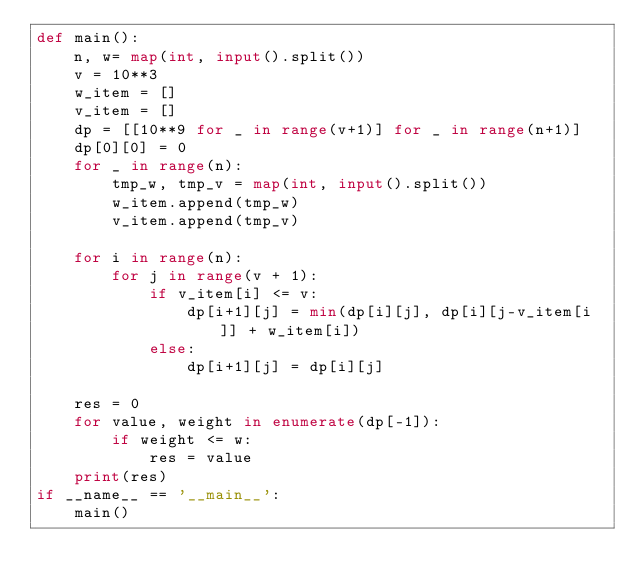<code> <loc_0><loc_0><loc_500><loc_500><_Python_>def main():
    n, w= map(int, input().split())
    v = 10**3
    w_item = []
    v_item = []
    dp = [[10**9 for _ in range(v+1)] for _ in range(n+1)]
    dp[0][0] = 0
    for _ in range(n):
        tmp_w, tmp_v = map(int, input().split())
        w_item.append(tmp_w)
        v_item.append(tmp_v)

    for i in range(n):
        for j in range(v + 1):
            if v_item[i] <= v:
                dp[i+1][j] = min(dp[i][j], dp[i][j-v_item[i]] + w_item[i])
            else:
                dp[i+1][j] = dp[i][j]
    
    res = 0
    for value, weight in enumerate(dp[-1]):
        if weight <= w:
            res = value
    print(res)
if __name__ == '__main__':
    main()

</code> 